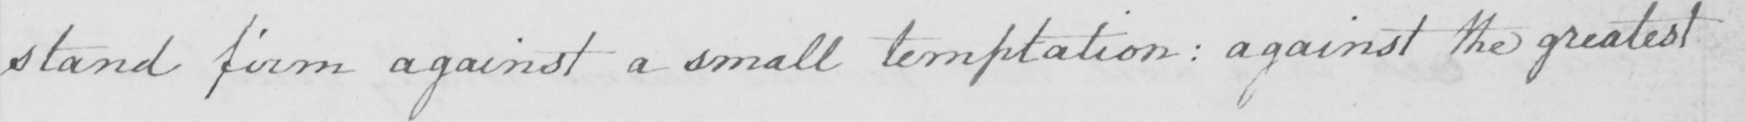Transcribe the text shown in this historical manuscript line. stand firm against a small temptation :  against the greatest 